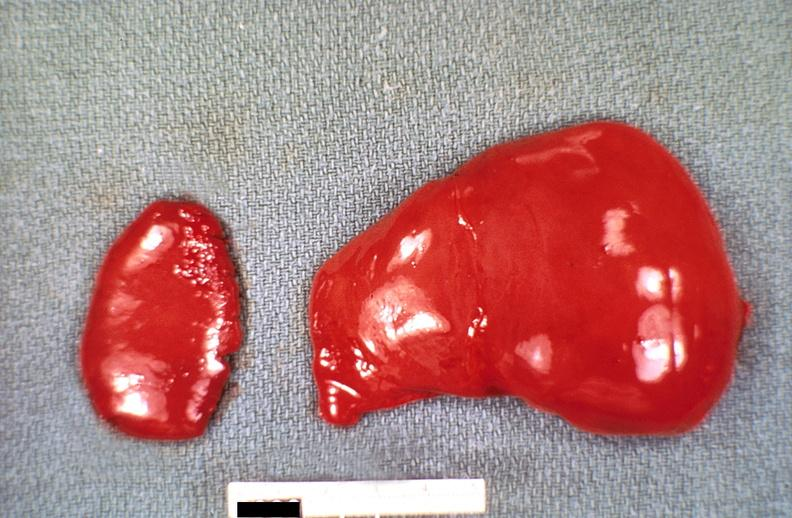what does this image show?
Answer the question using a single word or phrase. Liver and spleen 